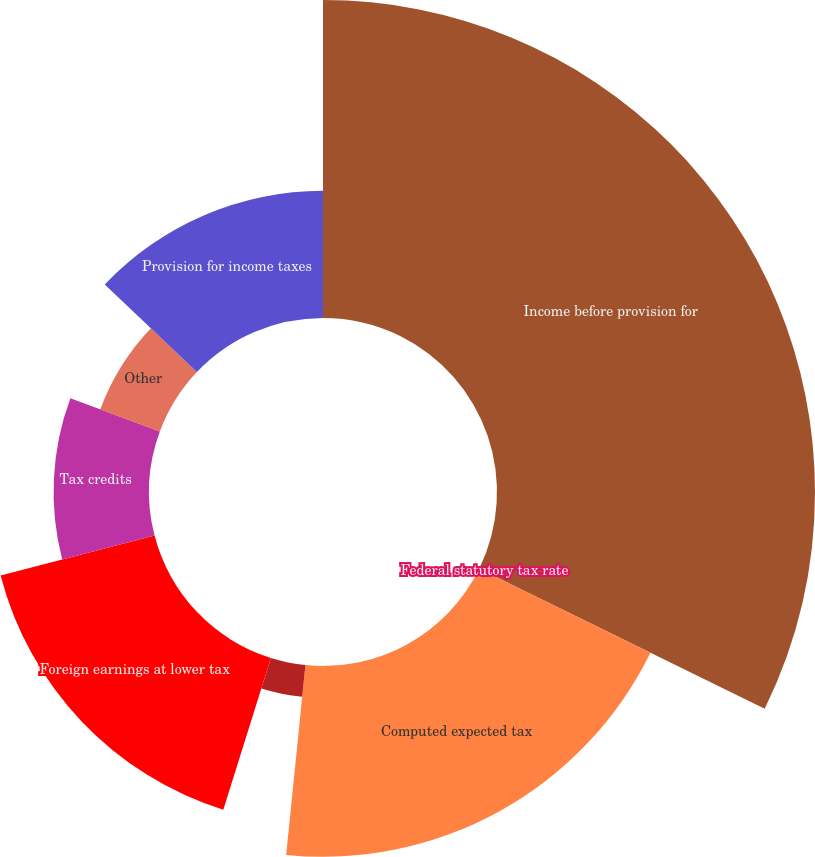Convert chart. <chart><loc_0><loc_0><loc_500><loc_500><pie_chart><fcel>Income before provision for<fcel>Federal statutory tax rate<fcel>Computed expected tax<fcel>State taxes net of federal<fcel>Foreign earnings at lower tax<fcel>Tax credits<fcel>Other<fcel>Provision for income taxes<nl><fcel>32.26%<fcel>0.0%<fcel>19.35%<fcel>3.23%<fcel>16.13%<fcel>9.68%<fcel>6.45%<fcel>12.9%<nl></chart> 